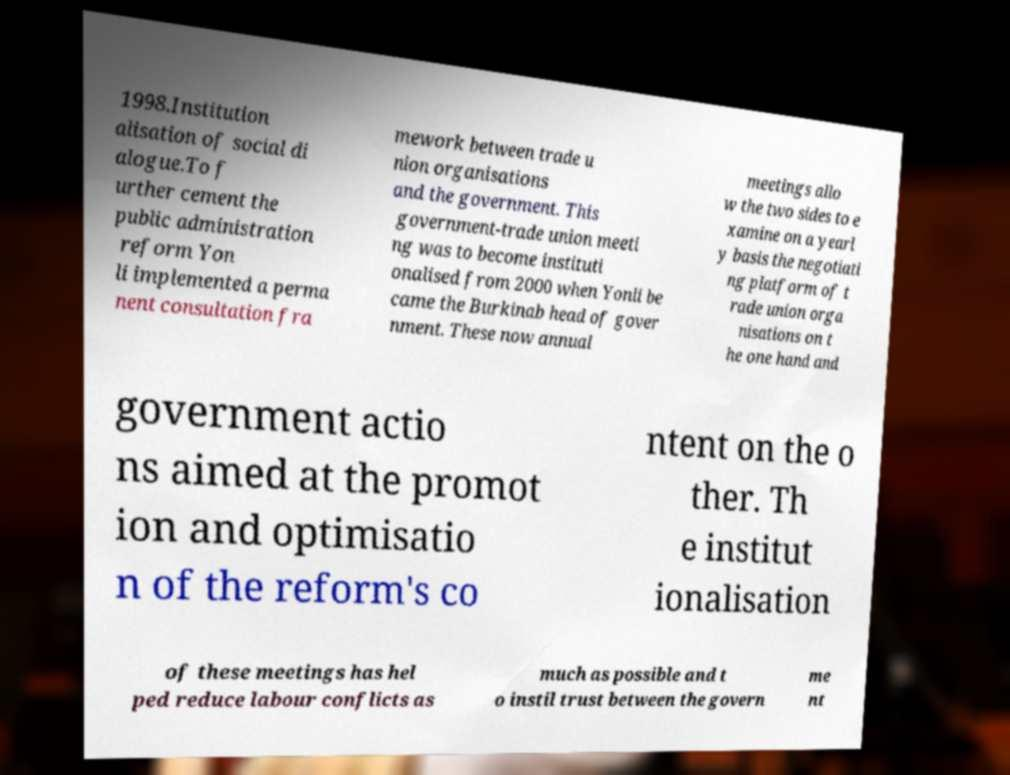For documentation purposes, I need the text within this image transcribed. Could you provide that? 1998.Institution alisation of social di alogue.To f urther cement the public administration reform Yon li implemented a perma nent consultation fra mework between trade u nion organisations and the government. This government-trade union meeti ng was to become instituti onalised from 2000 when Yonli be came the Burkinab head of gover nment. These now annual meetings allo w the two sides to e xamine on a yearl y basis the negotiati ng platform of t rade union orga nisations on t he one hand and government actio ns aimed at the promot ion and optimisatio n of the reform's co ntent on the o ther. Th e institut ionalisation of these meetings has hel ped reduce labour conflicts as much as possible and t o instil trust between the govern me nt 